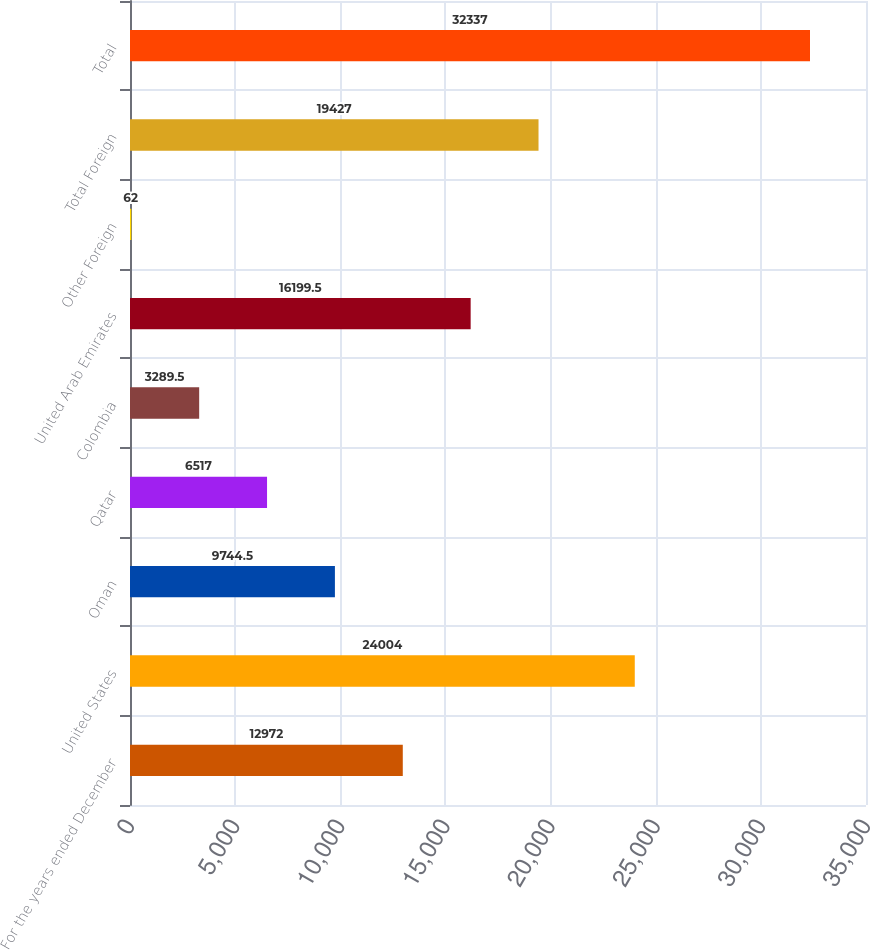Convert chart to OTSL. <chart><loc_0><loc_0><loc_500><loc_500><bar_chart><fcel>For the years ended December<fcel>United States<fcel>Oman<fcel>Qatar<fcel>Colombia<fcel>United Arab Emirates<fcel>Other Foreign<fcel>Total Foreign<fcel>Total<nl><fcel>12972<fcel>24004<fcel>9744.5<fcel>6517<fcel>3289.5<fcel>16199.5<fcel>62<fcel>19427<fcel>32337<nl></chart> 